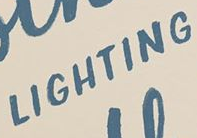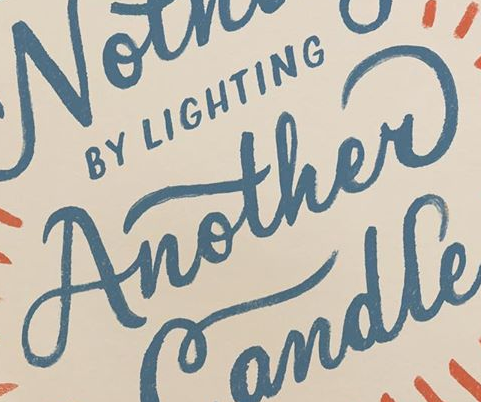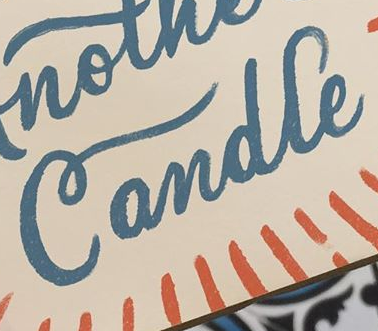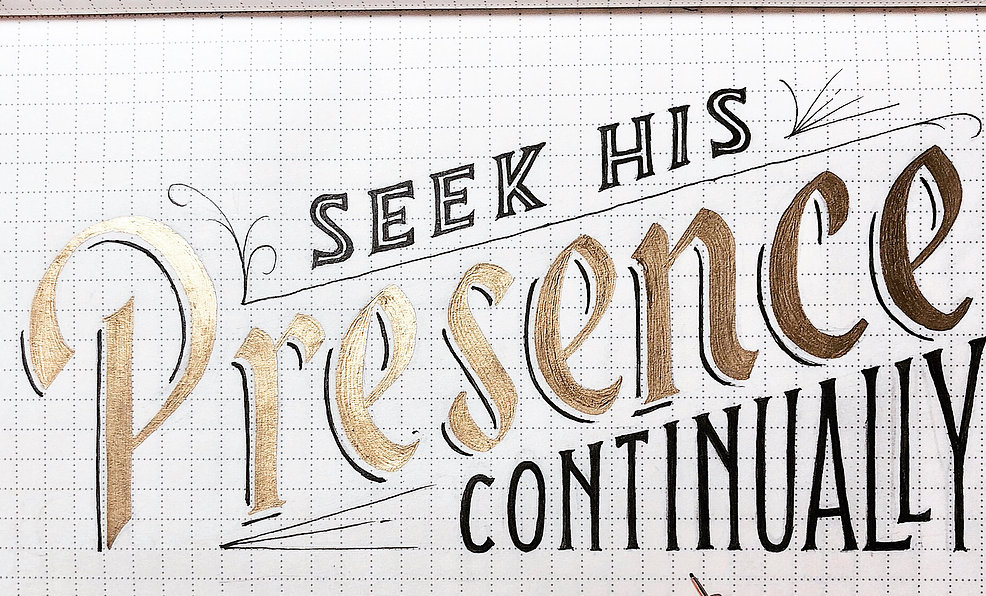Read the text content from these images in order, separated by a semicolon. LIGHTING; Another; Candle; Presence 